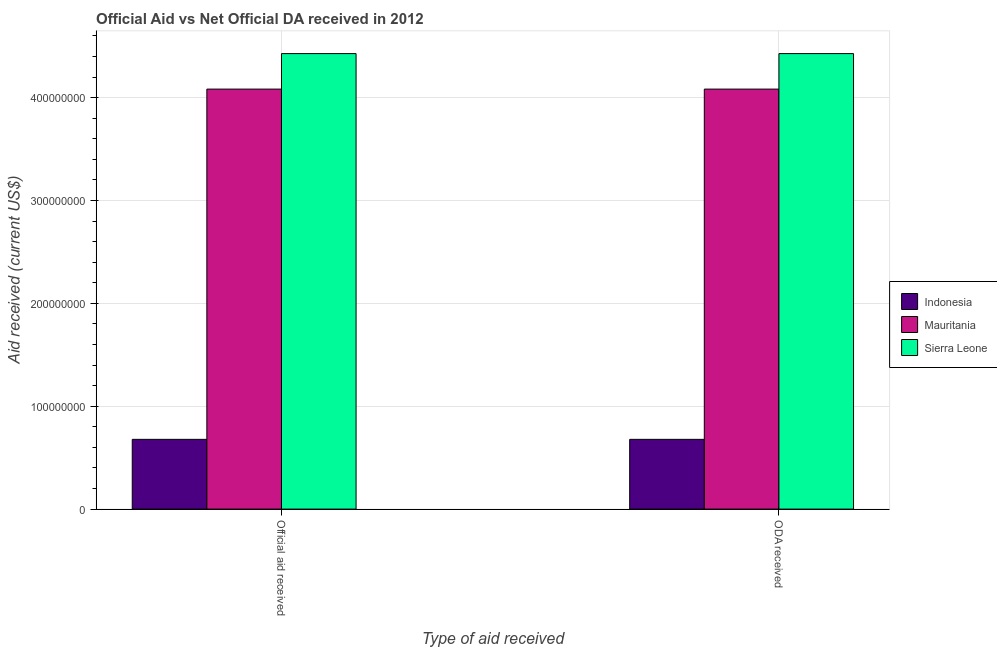Are the number of bars on each tick of the X-axis equal?
Offer a very short reply. Yes. How many bars are there on the 2nd tick from the right?
Your answer should be very brief. 3. What is the label of the 2nd group of bars from the left?
Your response must be concise. ODA received. What is the official aid received in Indonesia?
Provide a short and direct response. 6.78e+07. Across all countries, what is the maximum official aid received?
Offer a very short reply. 4.43e+08. Across all countries, what is the minimum oda received?
Provide a short and direct response. 6.78e+07. In which country was the oda received maximum?
Make the answer very short. Sierra Leone. In which country was the official aid received minimum?
Give a very brief answer. Indonesia. What is the total official aid received in the graph?
Make the answer very short. 9.19e+08. What is the difference between the official aid received in Mauritania and that in Indonesia?
Your answer should be very brief. 3.40e+08. What is the difference between the oda received in Mauritania and the official aid received in Sierra Leone?
Keep it short and to the point. -3.45e+07. What is the average official aid received per country?
Your answer should be very brief. 3.06e+08. In how many countries, is the official aid received greater than 140000000 US$?
Your response must be concise. 2. What is the ratio of the official aid received in Mauritania to that in Indonesia?
Keep it short and to the point. 6.02. Is the oda received in Indonesia less than that in Mauritania?
Offer a terse response. Yes. In how many countries, is the official aid received greater than the average official aid received taken over all countries?
Offer a very short reply. 2. What does the 3rd bar from the left in Official aid received represents?
Give a very brief answer. Sierra Leone. What does the 1st bar from the right in Official aid received represents?
Ensure brevity in your answer.  Sierra Leone. Are the values on the major ticks of Y-axis written in scientific E-notation?
Your response must be concise. No. How many legend labels are there?
Your answer should be very brief. 3. How are the legend labels stacked?
Offer a very short reply. Vertical. What is the title of the graph?
Offer a terse response. Official Aid vs Net Official DA received in 2012 . Does "Benin" appear as one of the legend labels in the graph?
Provide a succinct answer. No. What is the label or title of the X-axis?
Your answer should be very brief. Type of aid received. What is the label or title of the Y-axis?
Give a very brief answer. Aid received (current US$). What is the Aid received (current US$) of Indonesia in Official aid received?
Provide a short and direct response. 6.78e+07. What is the Aid received (current US$) in Mauritania in Official aid received?
Your answer should be compact. 4.08e+08. What is the Aid received (current US$) in Sierra Leone in Official aid received?
Your response must be concise. 4.43e+08. What is the Aid received (current US$) of Indonesia in ODA received?
Your response must be concise. 6.78e+07. What is the Aid received (current US$) in Mauritania in ODA received?
Offer a very short reply. 4.08e+08. What is the Aid received (current US$) of Sierra Leone in ODA received?
Ensure brevity in your answer.  4.43e+08. Across all Type of aid received, what is the maximum Aid received (current US$) of Indonesia?
Provide a short and direct response. 6.78e+07. Across all Type of aid received, what is the maximum Aid received (current US$) in Mauritania?
Offer a very short reply. 4.08e+08. Across all Type of aid received, what is the maximum Aid received (current US$) of Sierra Leone?
Offer a terse response. 4.43e+08. Across all Type of aid received, what is the minimum Aid received (current US$) of Indonesia?
Offer a very short reply. 6.78e+07. Across all Type of aid received, what is the minimum Aid received (current US$) in Mauritania?
Keep it short and to the point. 4.08e+08. Across all Type of aid received, what is the minimum Aid received (current US$) of Sierra Leone?
Your answer should be very brief. 4.43e+08. What is the total Aid received (current US$) in Indonesia in the graph?
Your answer should be very brief. 1.36e+08. What is the total Aid received (current US$) of Mauritania in the graph?
Provide a short and direct response. 8.17e+08. What is the total Aid received (current US$) of Sierra Leone in the graph?
Your answer should be compact. 8.86e+08. What is the difference between the Aid received (current US$) in Indonesia in Official aid received and that in ODA received?
Offer a terse response. 0. What is the difference between the Aid received (current US$) in Mauritania in Official aid received and that in ODA received?
Offer a very short reply. 0. What is the difference between the Aid received (current US$) of Sierra Leone in Official aid received and that in ODA received?
Make the answer very short. 0. What is the difference between the Aid received (current US$) in Indonesia in Official aid received and the Aid received (current US$) in Mauritania in ODA received?
Your answer should be very brief. -3.40e+08. What is the difference between the Aid received (current US$) of Indonesia in Official aid received and the Aid received (current US$) of Sierra Leone in ODA received?
Provide a succinct answer. -3.75e+08. What is the difference between the Aid received (current US$) of Mauritania in Official aid received and the Aid received (current US$) of Sierra Leone in ODA received?
Make the answer very short. -3.45e+07. What is the average Aid received (current US$) in Indonesia per Type of aid received?
Your answer should be very brief. 6.78e+07. What is the average Aid received (current US$) in Mauritania per Type of aid received?
Your answer should be compact. 4.08e+08. What is the average Aid received (current US$) in Sierra Leone per Type of aid received?
Give a very brief answer. 4.43e+08. What is the difference between the Aid received (current US$) of Indonesia and Aid received (current US$) of Mauritania in Official aid received?
Your answer should be very brief. -3.40e+08. What is the difference between the Aid received (current US$) in Indonesia and Aid received (current US$) in Sierra Leone in Official aid received?
Your answer should be compact. -3.75e+08. What is the difference between the Aid received (current US$) in Mauritania and Aid received (current US$) in Sierra Leone in Official aid received?
Your answer should be very brief. -3.45e+07. What is the difference between the Aid received (current US$) of Indonesia and Aid received (current US$) of Mauritania in ODA received?
Provide a short and direct response. -3.40e+08. What is the difference between the Aid received (current US$) in Indonesia and Aid received (current US$) in Sierra Leone in ODA received?
Your answer should be very brief. -3.75e+08. What is the difference between the Aid received (current US$) in Mauritania and Aid received (current US$) in Sierra Leone in ODA received?
Offer a terse response. -3.45e+07. What is the ratio of the Aid received (current US$) of Mauritania in Official aid received to that in ODA received?
Ensure brevity in your answer.  1. What is the ratio of the Aid received (current US$) of Sierra Leone in Official aid received to that in ODA received?
Offer a very short reply. 1. 